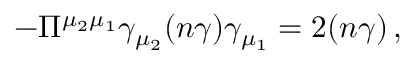<formula> <loc_0><loc_0><loc_500><loc_500>- \Pi ^ { \mu _ { 2 } \mu _ { 1 } } \gamma _ { \mu _ { 2 } } ( n \gamma ) \gamma _ { \mu _ { 1 } } = 2 ( n \gamma ) \, ,</formula> 